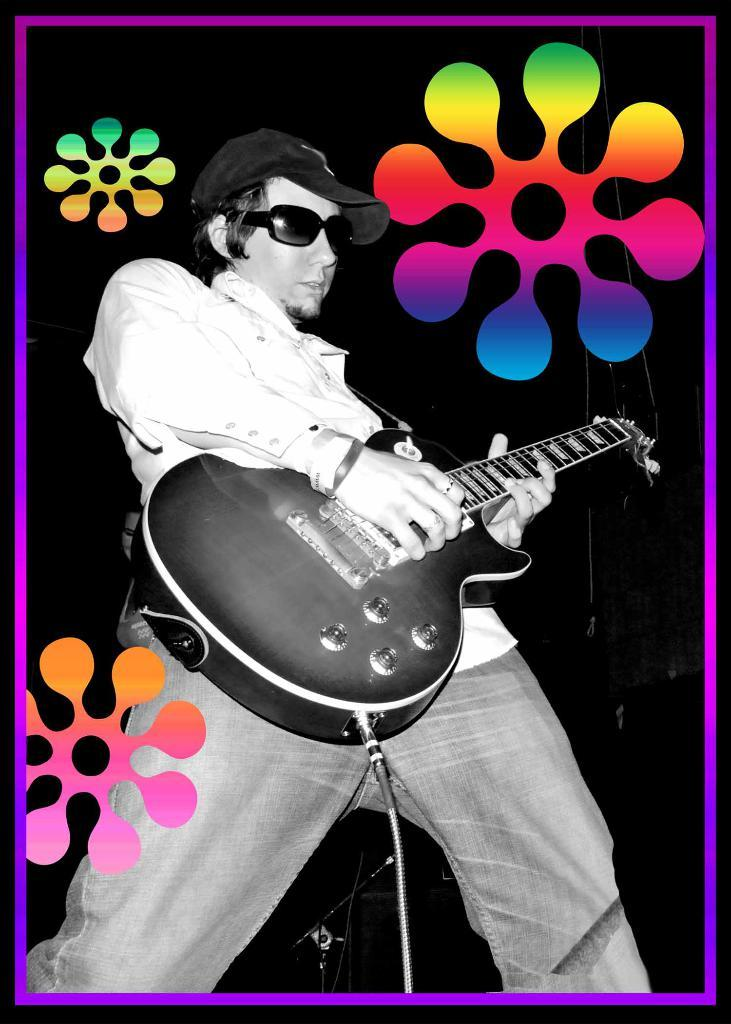What is the main subject of the image? The main subject of the image is a man. What is the man wearing on his head? The man is wearing a black color hat. What type of eyewear is the man wearing? The man is wearing goggles. What color is the shirt the man is wearing? The man is wearing a white color shirt. What object is the man holding in the image? The man is holding a guitar. How far away is the shop from the man in the image? There is no shop present in the image, so it is not possible to determine the distance between the man and a shop. 